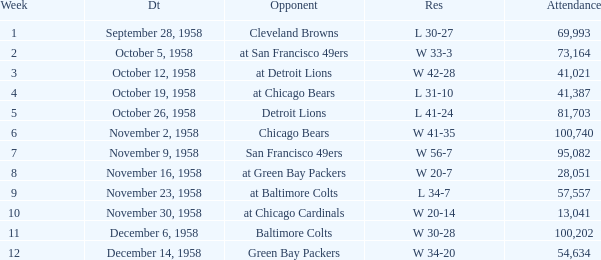Help me parse the entirety of this table. {'header': ['Week', 'Dt', 'Opponent', 'Res', 'Attendance'], 'rows': [['1', 'September 28, 1958', 'Cleveland Browns', 'L 30-27', '69,993'], ['2', 'October 5, 1958', 'at San Francisco 49ers', 'W 33-3', '73,164'], ['3', 'October 12, 1958', 'at Detroit Lions', 'W 42-28', '41,021'], ['4', 'October 19, 1958', 'at Chicago Bears', 'L 31-10', '41,387'], ['5', 'October 26, 1958', 'Detroit Lions', 'L 41-24', '81,703'], ['6', 'November 2, 1958', 'Chicago Bears', 'W 41-35', '100,740'], ['7', 'November 9, 1958', 'San Francisco 49ers', 'W 56-7', '95,082'], ['8', 'November 16, 1958', 'at Green Bay Packers', 'W 20-7', '28,051'], ['9', 'November 23, 1958', 'at Baltimore Colts', 'L 34-7', '57,557'], ['10', 'November 30, 1958', 'at Chicago Cardinals', 'W 20-14', '13,041'], ['11', 'December 6, 1958', 'Baltimore Colts', 'W 30-28', '100,202'], ['12', 'December 14, 1958', 'Green Bay Packers', 'W 34-20', '54,634']]} What was the higest attendance on November 9, 1958? 95082.0. 